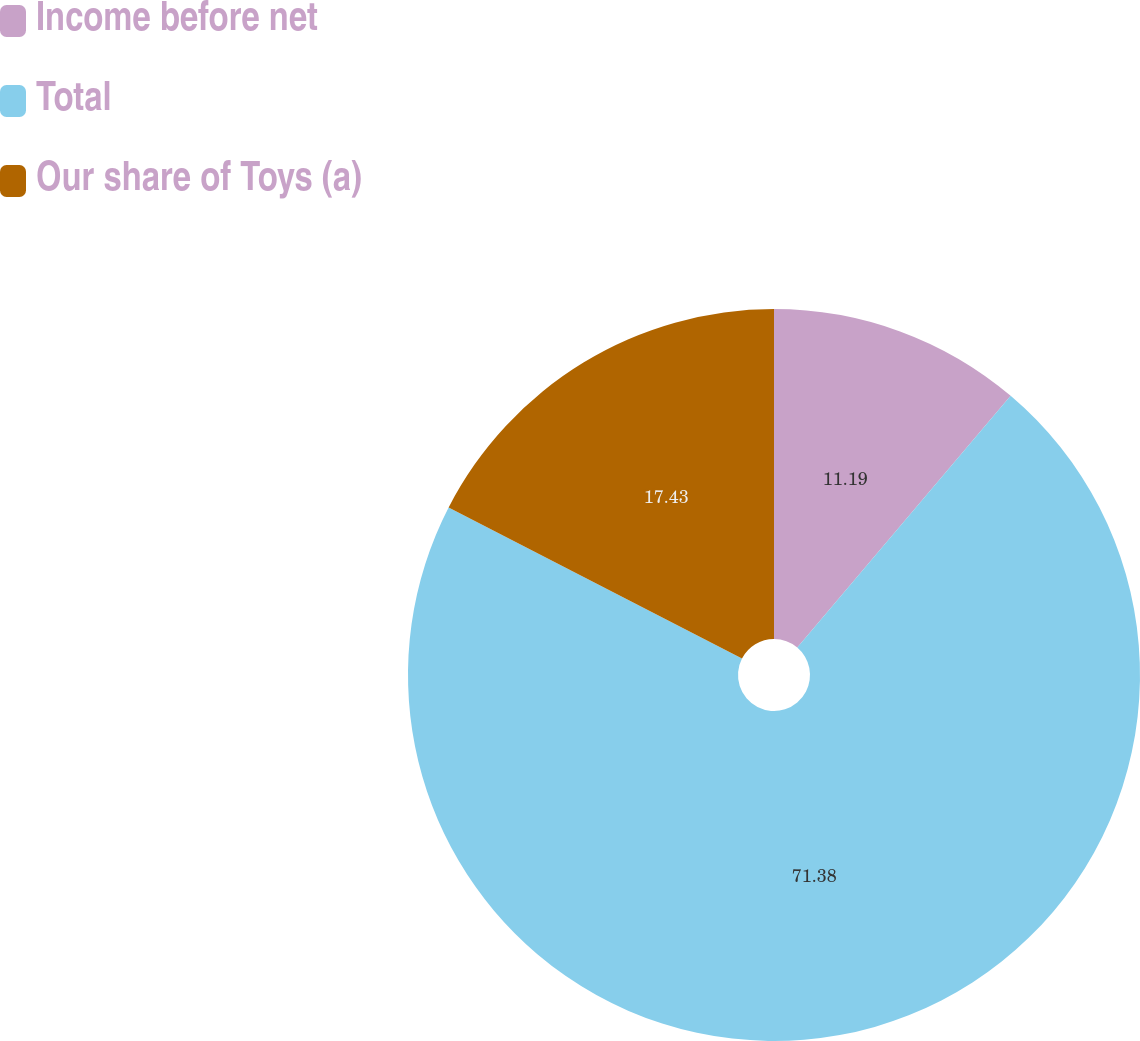Convert chart to OTSL. <chart><loc_0><loc_0><loc_500><loc_500><pie_chart><fcel>Income before net<fcel>Total<fcel>Our share of Toys (a)<nl><fcel>11.19%<fcel>71.38%<fcel>17.43%<nl></chart> 